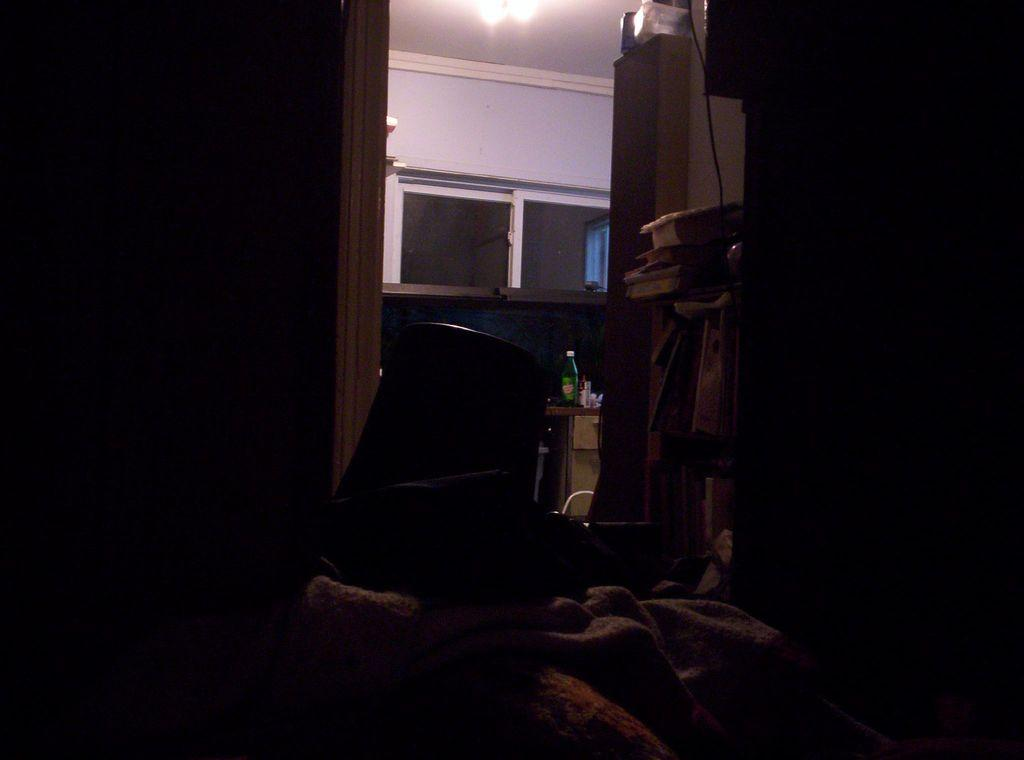What type of opening can be seen in the image? There is a window in the image. What type of structure is present in the image? There is a wall in the image. What can be used for illumination in the image? There is a light in the image. What type of rock is being used as a foundation for the government building in the image? There is no government building or rock present in the image. What type of love can be seen between the two people in the image? There are no people or any indication of love in the image. 